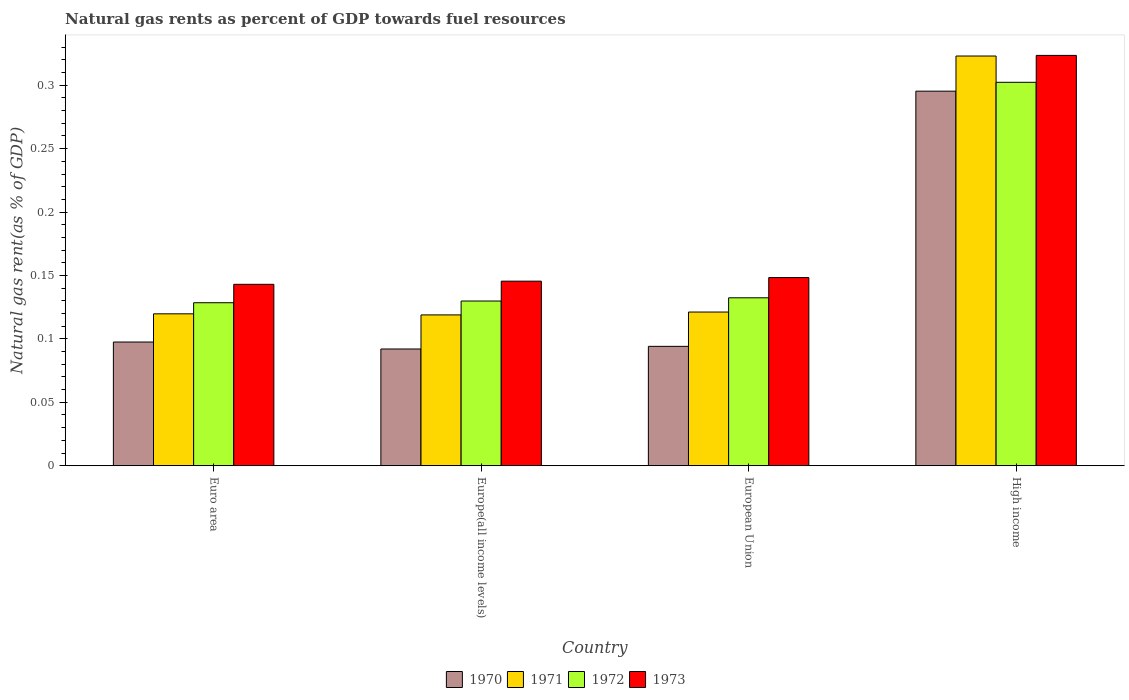Are the number of bars on each tick of the X-axis equal?
Offer a very short reply. Yes. How many bars are there on the 4th tick from the left?
Ensure brevity in your answer.  4. What is the label of the 1st group of bars from the left?
Your answer should be very brief. Euro area. In how many cases, is the number of bars for a given country not equal to the number of legend labels?
Make the answer very short. 0. What is the natural gas rent in 1971 in Europe(all income levels)?
Provide a short and direct response. 0.12. Across all countries, what is the maximum natural gas rent in 1972?
Offer a very short reply. 0.3. Across all countries, what is the minimum natural gas rent in 1970?
Keep it short and to the point. 0.09. In which country was the natural gas rent in 1971 maximum?
Provide a succinct answer. High income. In which country was the natural gas rent in 1972 minimum?
Make the answer very short. Euro area. What is the total natural gas rent in 1973 in the graph?
Offer a very short reply. 0.76. What is the difference between the natural gas rent in 1971 in Euro area and that in Europe(all income levels)?
Ensure brevity in your answer.  0. What is the difference between the natural gas rent in 1970 in High income and the natural gas rent in 1973 in Europe(all income levels)?
Your answer should be very brief. 0.15. What is the average natural gas rent in 1972 per country?
Offer a terse response. 0.17. What is the difference between the natural gas rent of/in 1973 and natural gas rent of/in 1972 in Euro area?
Your answer should be compact. 0.01. In how many countries, is the natural gas rent in 1972 greater than 0.23 %?
Offer a very short reply. 1. What is the ratio of the natural gas rent in 1971 in European Union to that in High income?
Keep it short and to the point. 0.38. Is the difference between the natural gas rent in 1973 in Europe(all income levels) and High income greater than the difference between the natural gas rent in 1972 in Europe(all income levels) and High income?
Your response must be concise. No. What is the difference between the highest and the second highest natural gas rent in 1972?
Ensure brevity in your answer.  0.17. What is the difference between the highest and the lowest natural gas rent in 1973?
Your response must be concise. 0.18. In how many countries, is the natural gas rent in 1972 greater than the average natural gas rent in 1972 taken over all countries?
Provide a succinct answer. 1. Is the sum of the natural gas rent in 1971 in Euro area and High income greater than the maximum natural gas rent in 1970 across all countries?
Your response must be concise. Yes. What does the 2nd bar from the right in Euro area represents?
Give a very brief answer. 1972. How many bars are there?
Offer a very short reply. 16. Are all the bars in the graph horizontal?
Keep it short and to the point. No. How many countries are there in the graph?
Give a very brief answer. 4. Are the values on the major ticks of Y-axis written in scientific E-notation?
Provide a short and direct response. No. Where does the legend appear in the graph?
Make the answer very short. Bottom center. How are the legend labels stacked?
Give a very brief answer. Horizontal. What is the title of the graph?
Offer a terse response. Natural gas rents as percent of GDP towards fuel resources. What is the label or title of the X-axis?
Provide a short and direct response. Country. What is the label or title of the Y-axis?
Keep it short and to the point. Natural gas rent(as % of GDP). What is the Natural gas rent(as % of GDP) of 1970 in Euro area?
Offer a terse response. 0.1. What is the Natural gas rent(as % of GDP) of 1971 in Euro area?
Provide a short and direct response. 0.12. What is the Natural gas rent(as % of GDP) in 1972 in Euro area?
Offer a very short reply. 0.13. What is the Natural gas rent(as % of GDP) of 1973 in Euro area?
Keep it short and to the point. 0.14. What is the Natural gas rent(as % of GDP) of 1970 in Europe(all income levels)?
Provide a succinct answer. 0.09. What is the Natural gas rent(as % of GDP) in 1971 in Europe(all income levels)?
Your answer should be compact. 0.12. What is the Natural gas rent(as % of GDP) in 1972 in Europe(all income levels)?
Offer a very short reply. 0.13. What is the Natural gas rent(as % of GDP) in 1973 in Europe(all income levels)?
Offer a terse response. 0.15. What is the Natural gas rent(as % of GDP) in 1970 in European Union?
Your response must be concise. 0.09. What is the Natural gas rent(as % of GDP) in 1971 in European Union?
Provide a short and direct response. 0.12. What is the Natural gas rent(as % of GDP) in 1972 in European Union?
Your answer should be compact. 0.13. What is the Natural gas rent(as % of GDP) in 1973 in European Union?
Provide a short and direct response. 0.15. What is the Natural gas rent(as % of GDP) in 1970 in High income?
Provide a short and direct response. 0.3. What is the Natural gas rent(as % of GDP) in 1971 in High income?
Offer a terse response. 0.32. What is the Natural gas rent(as % of GDP) in 1972 in High income?
Give a very brief answer. 0.3. What is the Natural gas rent(as % of GDP) in 1973 in High income?
Offer a very short reply. 0.32. Across all countries, what is the maximum Natural gas rent(as % of GDP) in 1970?
Your answer should be compact. 0.3. Across all countries, what is the maximum Natural gas rent(as % of GDP) in 1971?
Offer a terse response. 0.32. Across all countries, what is the maximum Natural gas rent(as % of GDP) in 1972?
Your answer should be compact. 0.3. Across all countries, what is the maximum Natural gas rent(as % of GDP) of 1973?
Offer a very short reply. 0.32. Across all countries, what is the minimum Natural gas rent(as % of GDP) in 1970?
Your response must be concise. 0.09. Across all countries, what is the minimum Natural gas rent(as % of GDP) of 1971?
Offer a very short reply. 0.12. Across all countries, what is the minimum Natural gas rent(as % of GDP) of 1972?
Provide a short and direct response. 0.13. Across all countries, what is the minimum Natural gas rent(as % of GDP) of 1973?
Your answer should be compact. 0.14. What is the total Natural gas rent(as % of GDP) in 1970 in the graph?
Your response must be concise. 0.58. What is the total Natural gas rent(as % of GDP) in 1971 in the graph?
Your answer should be compact. 0.68. What is the total Natural gas rent(as % of GDP) of 1972 in the graph?
Offer a terse response. 0.69. What is the total Natural gas rent(as % of GDP) in 1973 in the graph?
Your answer should be compact. 0.76. What is the difference between the Natural gas rent(as % of GDP) of 1970 in Euro area and that in Europe(all income levels)?
Make the answer very short. 0.01. What is the difference between the Natural gas rent(as % of GDP) of 1971 in Euro area and that in Europe(all income levels)?
Your response must be concise. 0. What is the difference between the Natural gas rent(as % of GDP) of 1972 in Euro area and that in Europe(all income levels)?
Make the answer very short. -0. What is the difference between the Natural gas rent(as % of GDP) of 1973 in Euro area and that in Europe(all income levels)?
Make the answer very short. -0. What is the difference between the Natural gas rent(as % of GDP) of 1970 in Euro area and that in European Union?
Provide a succinct answer. 0. What is the difference between the Natural gas rent(as % of GDP) of 1971 in Euro area and that in European Union?
Keep it short and to the point. -0. What is the difference between the Natural gas rent(as % of GDP) in 1972 in Euro area and that in European Union?
Keep it short and to the point. -0. What is the difference between the Natural gas rent(as % of GDP) in 1973 in Euro area and that in European Union?
Your answer should be very brief. -0.01. What is the difference between the Natural gas rent(as % of GDP) in 1970 in Euro area and that in High income?
Your answer should be very brief. -0.2. What is the difference between the Natural gas rent(as % of GDP) in 1971 in Euro area and that in High income?
Provide a succinct answer. -0.2. What is the difference between the Natural gas rent(as % of GDP) in 1972 in Euro area and that in High income?
Your answer should be very brief. -0.17. What is the difference between the Natural gas rent(as % of GDP) in 1973 in Euro area and that in High income?
Ensure brevity in your answer.  -0.18. What is the difference between the Natural gas rent(as % of GDP) of 1970 in Europe(all income levels) and that in European Union?
Offer a terse response. -0. What is the difference between the Natural gas rent(as % of GDP) of 1971 in Europe(all income levels) and that in European Union?
Give a very brief answer. -0. What is the difference between the Natural gas rent(as % of GDP) of 1972 in Europe(all income levels) and that in European Union?
Provide a succinct answer. -0. What is the difference between the Natural gas rent(as % of GDP) of 1973 in Europe(all income levels) and that in European Union?
Your response must be concise. -0. What is the difference between the Natural gas rent(as % of GDP) of 1970 in Europe(all income levels) and that in High income?
Your answer should be compact. -0.2. What is the difference between the Natural gas rent(as % of GDP) of 1971 in Europe(all income levels) and that in High income?
Ensure brevity in your answer.  -0.2. What is the difference between the Natural gas rent(as % of GDP) in 1972 in Europe(all income levels) and that in High income?
Ensure brevity in your answer.  -0.17. What is the difference between the Natural gas rent(as % of GDP) of 1973 in Europe(all income levels) and that in High income?
Keep it short and to the point. -0.18. What is the difference between the Natural gas rent(as % of GDP) in 1970 in European Union and that in High income?
Provide a succinct answer. -0.2. What is the difference between the Natural gas rent(as % of GDP) of 1971 in European Union and that in High income?
Give a very brief answer. -0.2. What is the difference between the Natural gas rent(as % of GDP) in 1972 in European Union and that in High income?
Provide a short and direct response. -0.17. What is the difference between the Natural gas rent(as % of GDP) in 1973 in European Union and that in High income?
Offer a terse response. -0.18. What is the difference between the Natural gas rent(as % of GDP) in 1970 in Euro area and the Natural gas rent(as % of GDP) in 1971 in Europe(all income levels)?
Your answer should be compact. -0.02. What is the difference between the Natural gas rent(as % of GDP) in 1970 in Euro area and the Natural gas rent(as % of GDP) in 1972 in Europe(all income levels)?
Provide a short and direct response. -0.03. What is the difference between the Natural gas rent(as % of GDP) in 1970 in Euro area and the Natural gas rent(as % of GDP) in 1973 in Europe(all income levels)?
Your response must be concise. -0.05. What is the difference between the Natural gas rent(as % of GDP) of 1971 in Euro area and the Natural gas rent(as % of GDP) of 1972 in Europe(all income levels)?
Ensure brevity in your answer.  -0.01. What is the difference between the Natural gas rent(as % of GDP) of 1971 in Euro area and the Natural gas rent(as % of GDP) of 1973 in Europe(all income levels)?
Offer a terse response. -0.03. What is the difference between the Natural gas rent(as % of GDP) of 1972 in Euro area and the Natural gas rent(as % of GDP) of 1973 in Europe(all income levels)?
Your answer should be compact. -0.02. What is the difference between the Natural gas rent(as % of GDP) in 1970 in Euro area and the Natural gas rent(as % of GDP) in 1971 in European Union?
Ensure brevity in your answer.  -0.02. What is the difference between the Natural gas rent(as % of GDP) in 1970 in Euro area and the Natural gas rent(as % of GDP) in 1972 in European Union?
Offer a very short reply. -0.03. What is the difference between the Natural gas rent(as % of GDP) of 1970 in Euro area and the Natural gas rent(as % of GDP) of 1973 in European Union?
Ensure brevity in your answer.  -0.05. What is the difference between the Natural gas rent(as % of GDP) of 1971 in Euro area and the Natural gas rent(as % of GDP) of 1972 in European Union?
Your answer should be compact. -0.01. What is the difference between the Natural gas rent(as % of GDP) in 1971 in Euro area and the Natural gas rent(as % of GDP) in 1973 in European Union?
Give a very brief answer. -0.03. What is the difference between the Natural gas rent(as % of GDP) of 1972 in Euro area and the Natural gas rent(as % of GDP) of 1973 in European Union?
Provide a short and direct response. -0.02. What is the difference between the Natural gas rent(as % of GDP) of 1970 in Euro area and the Natural gas rent(as % of GDP) of 1971 in High income?
Ensure brevity in your answer.  -0.23. What is the difference between the Natural gas rent(as % of GDP) in 1970 in Euro area and the Natural gas rent(as % of GDP) in 1972 in High income?
Provide a succinct answer. -0.2. What is the difference between the Natural gas rent(as % of GDP) in 1970 in Euro area and the Natural gas rent(as % of GDP) in 1973 in High income?
Offer a very short reply. -0.23. What is the difference between the Natural gas rent(as % of GDP) of 1971 in Euro area and the Natural gas rent(as % of GDP) of 1972 in High income?
Keep it short and to the point. -0.18. What is the difference between the Natural gas rent(as % of GDP) in 1971 in Euro area and the Natural gas rent(as % of GDP) in 1973 in High income?
Offer a terse response. -0.2. What is the difference between the Natural gas rent(as % of GDP) in 1972 in Euro area and the Natural gas rent(as % of GDP) in 1973 in High income?
Your answer should be compact. -0.2. What is the difference between the Natural gas rent(as % of GDP) in 1970 in Europe(all income levels) and the Natural gas rent(as % of GDP) in 1971 in European Union?
Keep it short and to the point. -0.03. What is the difference between the Natural gas rent(as % of GDP) of 1970 in Europe(all income levels) and the Natural gas rent(as % of GDP) of 1972 in European Union?
Your answer should be compact. -0.04. What is the difference between the Natural gas rent(as % of GDP) in 1970 in Europe(all income levels) and the Natural gas rent(as % of GDP) in 1973 in European Union?
Offer a terse response. -0.06. What is the difference between the Natural gas rent(as % of GDP) of 1971 in Europe(all income levels) and the Natural gas rent(as % of GDP) of 1972 in European Union?
Your response must be concise. -0.01. What is the difference between the Natural gas rent(as % of GDP) in 1971 in Europe(all income levels) and the Natural gas rent(as % of GDP) in 1973 in European Union?
Your response must be concise. -0.03. What is the difference between the Natural gas rent(as % of GDP) in 1972 in Europe(all income levels) and the Natural gas rent(as % of GDP) in 1973 in European Union?
Your answer should be compact. -0.02. What is the difference between the Natural gas rent(as % of GDP) of 1970 in Europe(all income levels) and the Natural gas rent(as % of GDP) of 1971 in High income?
Ensure brevity in your answer.  -0.23. What is the difference between the Natural gas rent(as % of GDP) of 1970 in Europe(all income levels) and the Natural gas rent(as % of GDP) of 1972 in High income?
Your response must be concise. -0.21. What is the difference between the Natural gas rent(as % of GDP) of 1970 in Europe(all income levels) and the Natural gas rent(as % of GDP) of 1973 in High income?
Your response must be concise. -0.23. What is the difference between the Natural gas rent(as % of GDP) of 1971 in Europe(all income levels) and the Natural gas rent(as % of GDP) of 1972 in High income?
Your response must be concise. -0.18. What is the difference between the Natural gas rent(as % of GDP) of 1971 in Europe(all income levels) and the Natural gas rent(as % of GDP) of 1973 in High income?
Offer a terse response. -0.2. What is the difference between the Natural gas rent(as % of GDP) in 1972 in Europe(all income levels) and the Natural gas rent(as % of GDP) in 1973 in High income?
Make the answer very short. -0.19. What is the difference between the Natural gas rent(as % of GDP) in 1970 in European Union and the Natural gas rent(as % of GDP) in 1971 in High income?
Provide a succinct answer. -0.23. What is the difference between the Natural gas rent(as % of GDP) of 1970 in European Union and the Natural gas rent(as % of GDP) of 1972 in High income?
Offer a very short reply. -0.21. What is the difference between the Natural gas rent(as % of GDP) in 1970 in European Union and the Natural gas rent(as % of GDP) in 1973 in High income?
Provide a succinct answer. -0.23. What is the difference between the Natural gas rent(as % of GDP) of 1971 in European Union and the Natural gas rent(as % of GDP) of 1972 in High income?
Your answer should be compact. -0.18. What is the difference between the Natural gas rent(as % of GDP) in 1971 in European Union and the Natural gas rent(as % of GDP) in 1973 in High income?
Provide a short and direct response. -0.2. What is the difference between the Natural gas rent(as % of GDP) of 1972 in European Union and the Natural gas rent(as % of GDP) of 1973 in High income?
Give a very brief answer. -0.19. What is the average Natural gas rent(as % of GDP) in 1970 per country?
Ensure brevity in your answer.  0.14. What is the average Natural gas rent(as % of GDP) of 1971 per country?
Make the answer very short. 0.17. What is the average Natural gas rent(as % of GDP) of 1972 per country?
Make the answer very short. 0.17. What is the average Natural gas rent(as % of GDP) of 1973 per country?
Make the answer very short. 0.19. What is the difference between the Natural gas rent(as % of GDP) of 1970 and Natural gas rent(as % of GDP) of 1971 in Euro area?
Make the answer very short. -0.02. What is the difference between the Natural gas rent(as % of GDP) of 1970 and Natural gas rent(as % of GDP) of 1972 in Euro area?
Offer a terse response. -0.03. What is the difference between the Natural gas rent(as % of GDP) in 1970 and Natural gas rent(as % of GDP) in 1973 in Euro area?
Your answer should be compact. -0.05. What is the difference between the Natural gas rent(as % of GDP) in 1971 and Natural gas rent(as % of GDP) in 1972 in Euro area?
Keep it short and to the point. -0.01. What is the difference between the Natural gas rent(as % of GDP) in 1971 and Natural gas rent(as % of GDP) in 1973 in Euro area?
Provide a short and direct response. -0.02. What is the difference between the Natural gas rent(as % of GDP) in 1972 and Natural gas rent(as % of GDP) in 1973 in Euro area?
Your response must be concise. -0.01. What is the difference between the Natural gas rent(as % of GDP) in 1970 and Natural gas rent(as % of GDP) in 1971 in Europe(all income levels)?
Your answer should be compact. -0.03. What is the difference between the Natural gas rent(as % of GDP) in 1970 and Natural gas rent(as % of GDP) in 1972 in Europe(all income levels)?
Give a very brief answer. -0.04. What is the difference between the Natural gas rent(as % of GDP) of 1970 and Natural gas rent(as % of GDP) of 1973 in Europe(all income levels)?
Your answer should be very brief. -0.05. What is the difference between the Natural gas rent(as % of GDP) in 1971 and Natural gas rent(as % of GDP) in 1972 in Europe(all income levels)?
Offer a terse response. -0.01. What is the difference between the Natural gas rent(as % of GDP) of 1971 and Natural gas rent(as % of GDP) of 1973 in Europe(all income levels)?
Keep it short and to the point. -0.03. What is the difference between the Natural gas rent(as % of GDP) of 1972 and Natural gas rent(as % of GDP) of 1973 in Europe(all income levels)?
Ensure brevity in your answer.  -0.02. What is the difference between the Natural gas rent(as % of GDP) of 1970 and Natural gas rent(as % of GDP) of 1971 in European Union?
Provide a short and direct response. -0.03. What is the difference between the Natural gas rent(as % of GDP) in 1970 and Natural gas rent(as % of GDP) in 1972 in European Union?
Provide a short and direct response. -0.04. What is the difference between the Natural gas rent(as % of GDP) of 1970 and Natural gas rent(as % of GDP) of 1973 in European Union?
Provide a short and direct response. -0.05. What is the difference between the Natural gas rent(as % of GDP) in 1971 and Natural gas rent(as % of GDP) in 1972 in European Union?
Provide a succinct answer. -0.01. What is the difference between the Natural gas rent(as % of GDP) of 1971 and Natural gas rent(as % of GDP) of 1973 in European Union?
Your answer should be very brief. -0.03. What is the difference between the Natural gas rent(as % of GDP) of 1972 and Natural gas rent(as % of GDP) of 1973 in European Union?
Offer a terse response. -0.02. What is the difference between the Natural gas rent(as % of GDP) in 1970 and Natural gas rent(as % of GDP) in 1971 in High income?
Offer a terse response. -0.03. What is the difference between the Natural gas rent(as % of GDP) of 1970 and Natural gas rent(as % of GDP) of 1972 in High income?
Make the answer very short. -0.01. What is the difference between the Natural gas rent(as % of GDP) of 1970 and Natural gas rent(as % of GDP) of 1973 in High income?
Offer a very short reply. -0.03. What is the difference between the Natural gas rent(as % of GDP) of 1971 and Natural gas rent(as % of GDP) of 1972 in High income?
Give a very brief answer. 0.02. What is the difference between the Natural gas rent(as % of GDP) in 1971 and Natural gas rent(as % of GDP) in 1973 in High income?
Your response must be concise. -0. What is the difference between the Natural gas rent(as % of GDP) of 1972 and Natural gas rent(as % of GDP) of 1973 in High income?
Offer a terse response. -0.02. What is the ratio of the Natural gas rent(as % of GDP) in 1970 in Euro area to that in Europe(all income levels)?
Your answer should be compact. 1.06. What is the ratio of the Natural gas rent(as % of GDP) in 1973 in Euro area to that in Europe(all income levels)?
Give a very brief answer. 0.98. What is the ratio of the Natural gas rent(as % of GDP) of 1970 in Euro area to that in European Union?
Provide a succinct answer. 1.04. What is the ratio of the Natural gas rent(as % of GDP) of 1971 in Euro area to that in European Union?
Provide a succinct answer. 0.99. What is the ratio of the Natural gas rent(as % of GDP) in 1972 in Euro area to that in European Union?
Provide a succinct answer. 0.97. What is the ratio of the Natural gas rent(as % of GDP) in 1973 in Euro area to that in European Union?
Your answer should be compact. 0.96. What is the ratio of the Natural gas rent(as % of GDP) in 1970 in Euro area to that in High income?
Your answer should be very brief. 0.33. What is the ratio of the Natural gas rent(as % of GDP) of 1971 in Euro area to that in High income?
Give a very brief answer. 0.37. What is the ratio of the Natural gas rent(as % of GDP) of 1972 in Euro area to that in High income?
Make the answer very short. 0.43. What is the ratio of the Natural gas rent(as % of GDP) in 1973 in Euro area to that in High income?
Ensure brevity in your answer.  0.44. What is the ratio of the Natural gas rent(as % of GDP) in 1970 in Europe(all income levels) to that in European Union?
Make the answer very short. 0.98. What is the ratio of the Natural gas rent(as % of GDP) of 1971 in Europe(all income levels) to that in European Union?
Your answer should be very brief. 0.98. What is the ratio of the Natural gas rent(as % of GDP) in 1972 in Europe(all income levels) to that in European Union?
Offer a very short reply. 0.98. What is the ratio of the Natural gas rent(as % of GDP) in 1973 in Europe(all income levels) to that in European Union?
Your answer should be very brief. 0.98. What is the ratio of the Natural gas rent(as % of GDP) of 1970 in Europe(all income levels) to that in High income?
Ensure brevity in your answer.  0.31. What is the ratio of the Natural gas rent(as % of GDP) in 1971 in Europe(all income levels) to that in High income?
Your answer should be very brief. 0.37. What is the ratio of the Natural gas rent(as % of GDP) of 1972 in Europe(all income levels) to that in High income?
Give a very brief answer. 0.43. What is the ratio of the Natural gas rent(as % of GDP) in 1973 in Europe(all income levels) to that in High income?
Give a very brief answer. 0.45. What is the ratio of the Natural gas rent(as % of GDP) of 1970 in European Union to that in High income?
Keep it short and to the point. 0.32. What is the ratio of the Natural gas rent(as % of GDP) in 1971 in European Union to that in High income?
Your answer should be very brief. 0.38. What is the ratio of the Natural gas rent(as % of GDP) in 1972 in European Union to that in High income?
Your answer should be very brief. 0.44. What is the ratio of the Natural gas rent(as % of GDP) of 1973 in European Union to that in High income?
Give a very brief answer. 0.46. What is the difference between the highest and the second highest Natural gas rent(as % of GDP) in 1970?
Provide a succinct answer. 0.2. What is the difference between the highest and the second highest Natural gas rent(as % of GDP) of 1971?
Provide a succinct answer. 0.2. What is the difference between the highest and the second highest Natural gas rent(as % of GDP) of 1972?
Your answer should be compact. 0.17. What is the difference between the highest and the second highest Natural gas rent(as % of GDP) in 1973?
Offer a terse response. 0.18. What is the difference between the highest and the lowest Natural gas rent(as % of GDP) of 1970?
Your response must be concise. 0.2. What is the difference between the highest and the lowest Natural gas rent(as % of GDP) in 1971?
Provide a short and direct response. 0.2. What is the difference between the highest and the lowest Natural gas rent(as % of GDP) of 1972?
Ensure brevity in your answer.  0.17. What is the difference between the highest and the lowest Natural gas rent(as % of GDP) of 1973?
Give a very brief answer. 0.18. 